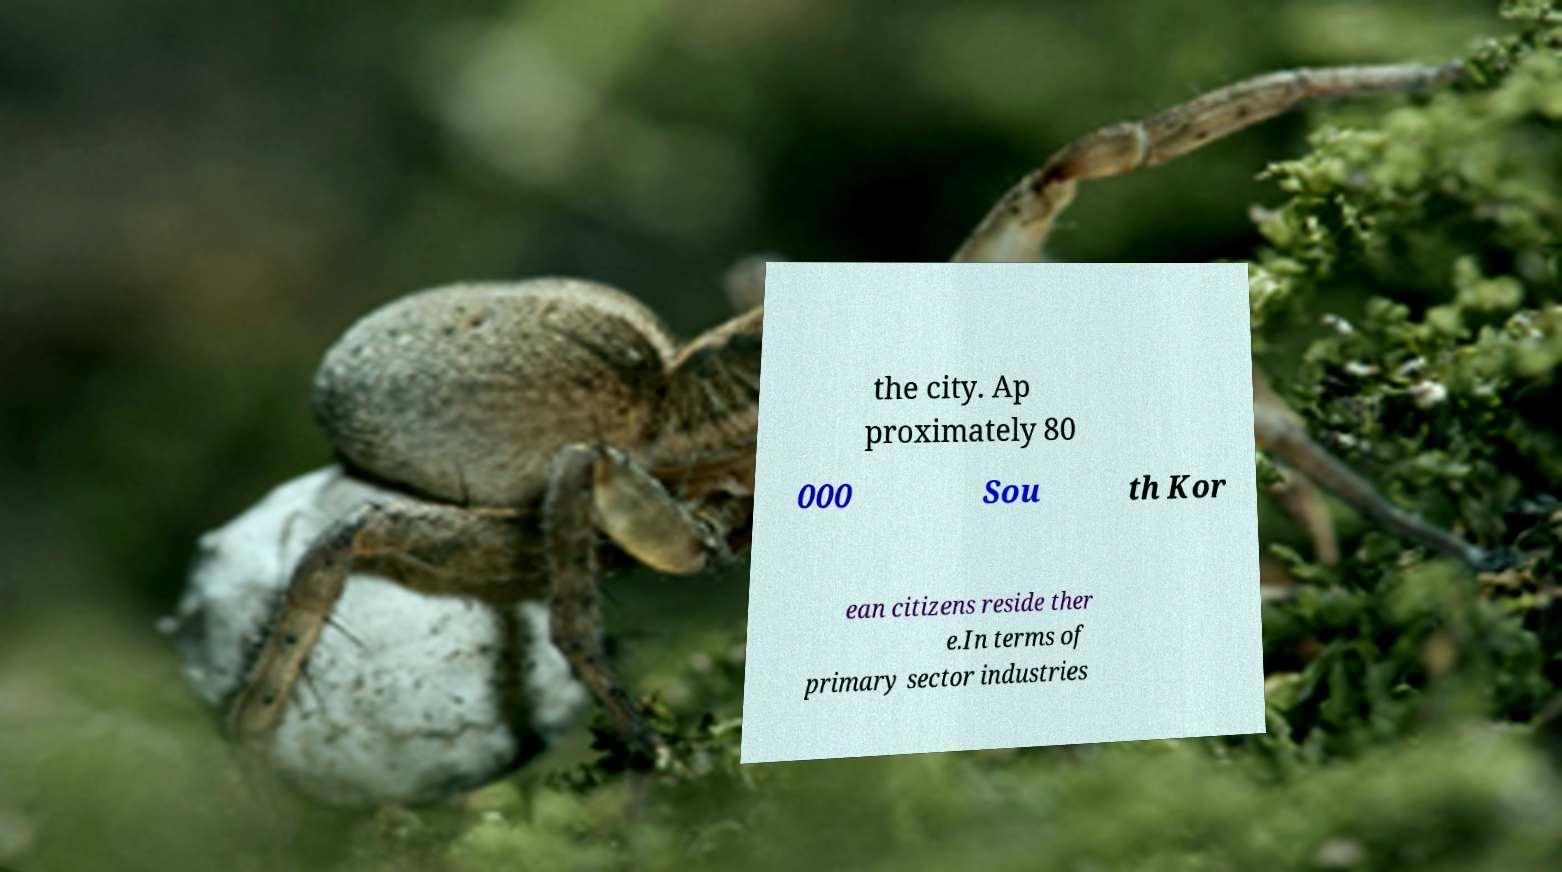Could you extract and type out the text from this image? the city. Ap proximately 80 000 Sou th Kor ean citizens reside ther e.In terms of primary sector industries 